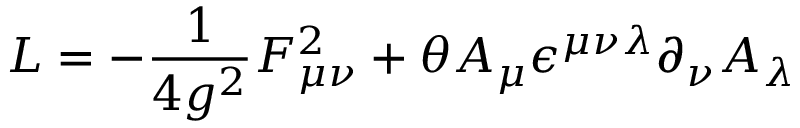<formula> <loc_0><loc_0><loc_500><loc_500>{ \sl L } = - \frac { 1 } { 4 g ^ { 2 } } F _ { \mu \nu } ^ { 2 } + \theta A _ { \mu } \epsilon ^ { \mu \nu \lambda } \partial _ { \nu } A _ { \lambda }</formula> 